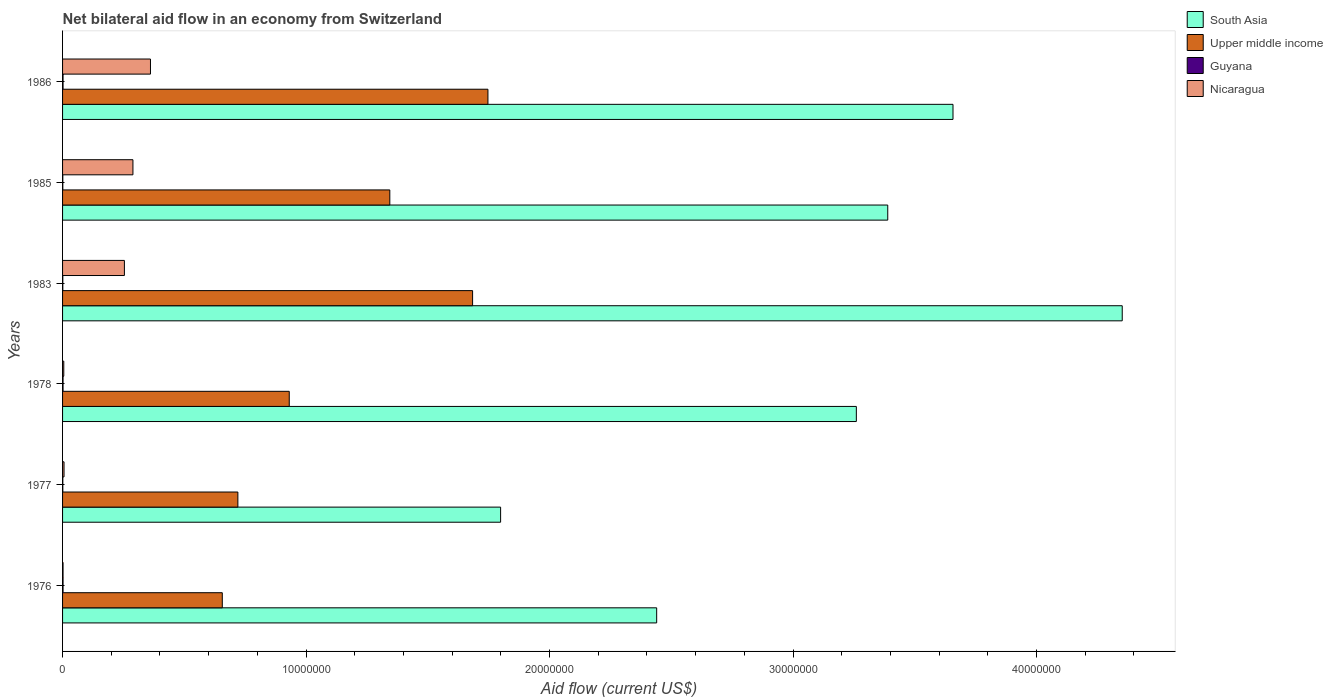How many different coloured bars are there?
Make the answer very short. 4. How many groups of bars are there?
Ensure brevity in your answer.  6. Are the number of bars per tick equal to the number of legend labels?
Offer a very short reply. Yes. Are the number of bars on each tick of the Y-axis equal?
Offer a very short reply. Yes. How many bars are there on the 6th tick from the bottom?
Offer a terse response. 4. What is the label of the 2nd group of bars from the top?
Provide a succinct answer. 1985. In how many cases, is the number of bars for a given year not equal to the number of legend labels?
Your answer should be compact. 0. What is the net bilateral aid flow in Guyana in 1985?
Your answer should be compact. 10000. Across all years, what is the maximum net bilateral aid flow in Upper middle income?
Give a very brief answer. 1.75e+07. In which year was the net bilateral aid flow in Guyana maximum?
Give a very brief answer. 1976. In which year was the net bilateral aid flow in Upper middle income minimum?
Your response must be concise. 1976. What is the total net bilateral aid flow in Upper middle income in the graph?
Your answer should be compact. 7.08e+07. What is the difference between the net bilateral aid flow in South Asia in 1976 and that in 1978?
Offer a terse response. -8.20e+06. What is the difference between the net bilateral aid flow in South Asia in 1977 and the net bilateral aid flow in Nicaragua in 1985?
Keep it short and to the point. 1.51e+07. What is the average net bilateral aid flow in South Asia per year?
Make the answer very short. 3.15e+07. In the year 1977, what is the difference between the net bilateral aid flow in Nicaragua and net bilateral aid flow in Upper middle income?
Offer a very short reply. -7.14e+06. What is the ratio of the net bilateral aid flow in Guyana in 1983 to that in 1986?
Your answer should be very brief. 0.5. Is the net bilateral aid flow in Upper middle income in 1978 less than that in 1985?
Your response must be concise. Yes. What is the difference between the highest and the lowest net bilateral aid flow in South Asia?
Provide a short and direct response. 2.55e+07. In how many years, is the net bilateral aid flow in Nicaragua greater than the average net bilateral aid flow in Nicaragua taken over all years?
Provide a succinct answer. 3. Is the sum of the net bilateral aid flow in Upper middle income in 1985 and 1986 greater than the maximum net bilateral aid flow in Nicaragua across all years?
Offer a terse response. Yes. Is it the case that in every year, the sum of the net bilateral aid flow in Upper middle income and net bilateral aid flow in Guyana is greater than the sum of net bilateral aid flow in South Asia and net bilateral aid flow in Nicaragua?
Provide a short and direct response. No. What does the 2nd bar from the top in 1986 represents?
Provide a short and direct response. Guyana. What does the 2nd bar from the bottom in 1986 represents?
Offer a terse response. Upper middle income. How many bars are there?
Provide a short and direct response. 24. Are all the bars in the graph horizontal?
Your response must be concise. Yes. How many years are there in the graph?
Provide a short and direct response. 6. What is the difference between two consecutive major ticks on the X-axis?
Ensure brevity in your answer.  1.00e+07. Are the values on the major ticks of X-axis written in scientific E-notation?
Your answer should be very brief. No. Does the graph contain any zero values?
Offer a very short reply. No. Does the graph contain grids?
Offer a terse response. No. Where does the legend appear in the graph?
Your response must be concise. Top right. How many legend labels are there?
Your answer should be very brief. 4. What is the title of the graph?
Give a very brief answer. Net bilateral aid flow in an economy from Switzerland. Does "Greece" appear as one of the legend labels in the graph?
Give a very brief answer. No. What is the label or title of the X-axis?
Offer a very short reply. Aid flow (current US$). What is the Aid flow (current US$) of South Asia in 1976?
Your answer should be compact. 2.44e+07. What is the Aid flow (current US$) of Upper middle income in 1976?
Give a very brief answer. 6.56e+06. What is the Aid flow (current US$) in Guyana in 1976?
Give a very brief answer. 2.00e+04. What is the Aid flow (current US$) in Nicaragua in 1976?
Your answer should be compact. 2.00e+04. What is the Aid flow (current US$) in South Asia in 1977?
Ensure brevity in your answer.  1.80e+07. What is the Aid flow (current US$) of Upper middle income in 1977?
Provide a short and direct response. 7.20e+06. What is the Aid flow (current US$) of Guyana in 1977?
Ensure brevity in your answer.  10000. What is the Aid flow (current US$) of South Asia in 1978?
Offer a very short reply. 3.26e+07. What is the Aid flow (current US$) of Upper middle income in 1978?
Keep it short and to the point. 9.31e+06. What is the Aid flow (current US$) in Nicaragua in 1978?
Keep it short and to the point. 5.00e+04. What is the Aid flow (current US$) of South Asia in 1983?
Make the answer very short. 4.35e+07. What is the Aid flow (current US$) in Upper middle income in 1983?
Keep it short and to the point. 1.68e+07. What is the Aid flow (current US$) in Guyana in 1983?
Make the answer very short. 10000. What is the Aid flow (current US$) in Nicaragua in 1983?
Your answer should be compact. 2.54e+06. What is the Aid flow (current US$) in South Asia in 1985?
Your answer should be very brief. 3.39e+07. What is the Aid flow (current US$) of Upper middle income in 1985?
Your answer should be compact. 1.34e+07. What is the Aid flow (current US$) in Guyana in 1985?
Keep it short and to the point. 10000. What is the Aid flow (current US$) of Nicaragua in 1985?
Your answer should be compact. 2.89e+06. What is the Aid flow (current US$) of South Asia in 1986?
Provide a short and direct response. 3.66e+07. What is the Aid flow (current US$) of Upper middle income in 1986?
Keep it short and to the point. 1.75e+07. What is the Aid flow (current US$) in Nicaragua in 1986?
Your answer should be very brief. 3.61e+06. Across all years, what is the maximum Aid flow (current US$) of South Asia?
Keep it short and to the point. 4.35e+07. Across all years, what is the maximum Aid flow (current US$) in Upper middle income?
Offer a terse response. 1.75e+07. Across all years, what is the maximum Aid flow (current US$) of Nicaragua?
Your answer should be compact. 3.61e+06. Across all years, what is the minimum Aid flow (current US$) in South Asia?
Give a very brief answer. 1.80e+07. Across all years, what is the minimum Aid flow (current US$) in Upper middle income?
Your response must be concise. 6.56e+06. Across all years, what is the minimum Aid flow (current US$) of Guyana?
Offer a very short reply. 10000. What is the total Aid flow (current US$) of South Asia in the graph?
Keep it short and to the point. 1.89e+08. What is the total Aid flow (current US$) of Upper middle income in the graph?
Provide a short and direct response. 7.08e+07. What is the total Aid flow (current US$) in Guyana in the graph?
Provide a succinct answer. 9.00e+04. What is the total Aid flow (current US$) of Nicaragua in the graph?
Your answer should be compact. 9.17e+06. What is the difference between the Aid flow (current US$) in South Asia in 1976 and that in 1977?
Your answer should be very brief. 6.41e+06. What is the difference between the Aid flow (current US$) in Upper middle income in 1976 and that in 1977?
Your response must be concise. -6.40e+05. What is the difference between the Aid flow (current US$) in Nicaragua in 1976 and that in 1977?
Your response must be concise. -4.00e+04. What is the difference between the Aid flow (current US$) of South Asia in 1976 and that in 1978?
Your answer should be compact. -8.20e+06. What is the difference between the Aid flow (current US$) in Upper middle income in 1976 and that in 1978?
Offer a terse response. -2.75e+06. What is the difference between the Aid flow (current US$) of South Asia in 1976 and that in 1983?
Provide a short and direct response. -1.91e+07. What is the difference between the Aid flow (current US$) of Upper middle income in 1976 and that in 1983?
Offer a very short reply. -1.03e+07. What is the difference between the Aid flow (current US$) of Nicaragua in 1976 and that in 1983?
Keep it short and to the point. -2.52e+06. What is the difference between the Aid flow (current US$) in South Asia in 1976 and that in 1985?
Make the answer very short. -9.49e+06. What is the difference between the Aid flow (current US$) in Upper middle income in 1976 and that in 1985?
Give a very brief answer. -6.88e+06. What is the difference between the Aid flow (current US$) of Nicaragua in 1976 and that in 1985?
Give a very brief answer. -2.87e+06. What is the difference between the Aid flow (current US$) of South Asia in 1976 and that in 1986?
Make the answer very short. -1.22e+07. What is the difference between the Aid flow (current US$) in Upper middle income in 1976 and that in 1986?
Keep it short and to the point. -1.09e+07. What is the difference between the Aid flow (current US$) of Guyana in 1976 and that in 1986?
Provide a short and direct response. 0. What is the difference between the Aid flow (current US$) in Nicaragua in 1976 and that in 1986?
Your response must be concise. -3.59e+06. What is the difference between the Aid flow (current US$) in South Asia in 1977 and that in 1978?
Provide a short and direct response. -1.46e+07. What is the difference between the Aid flow (current US$) in Upper middle income in 1977 and that in 1978?
Keep it short and to the point. -2.11e+06. What is the difference between the Aid flow (current US$) in South Asia in 1977 and that in 1983?
Offer a terse response. -2.55e+07. What is the difference between the Aid flow (current US$) in Upper middle income in 1977 and that in 1983?
Your answer should be very brief. -9.64e+06. What is the difference between the Aid flow (current US$) of Nicaragua in 1977 and that in 1983?
Offer a terse response. -2.48e+06. What is the difference between the Aid flow (current US$) of South Asia in 1977 and that in 1985?
Offer a very short reply. -1.59e+07. What is the difference between the Aid flow (current US$) in Upper middle income in 1977 and that in 1985?
Make the answer very short. -6.24e+06. What is the difference between the Aid flow (current US$) of Guyana in 1977 and that in 1985?
Keep it short and to the point. 0. What is the difference between the Aid flow (current US$) in Nicaragua in 1977 and that in 1985?
Make the answer very short. -2.83e+06. What is the difference between the Aid flow (current US$) in South Asia in 1977 and that in 1986?
Keep it short and to the point. -1.86e+07. What is the difference between the Aid flow (current US$) of Upper middle income in 1977 and that in 1986?
Keep it short and to the point. -1.03e+07. What is the difference between the Aid flow (current US$) of Guyana in 1977 and that in 1986?
Your answer should be very brief. -10000. What is the difference between the Aid flow (current US$) in Nicaragua in 1977 and that in 1986?
Offer a terse response. -3.55e+06. What is the difference between the Aid flow (current US$) of South Asia in 1978 and that in 1983?
Provide a succinct answer. -1.09e+07. What is the difference between the Aid flow (current US$) of Upper middle income in 1978 and that in 1983?
Your response must be concise. -7.53e+06. What is the difference between the Aid flow (current US$) of Nicaragua in 1978 and that in 1983?
Keep it short and to the point. -2.49e+06. What is the difference between the Aid flow (current US$) of South Asia in 1978 and that in 1985?
Your answer should be very brief. -1.29e+06. What is the difference between the Aid flow (current US$) in Upper middle income in 1978 and that in 1985?
Provide a succinct answer. -4.13e+06. What is the difference between the Aid flow (current US$) in Nicaragua in 1978 and that in 1985?
Provide a short and direct response. -2.84e+06. What is the difference between the Aid flow (current US$) in South Asia in 1978 and that in 1986?
Your answer should be very brief. -3.97e+06. What is the difference between the Aid flow (current US$) of Upper middle income in 1978 and that in 1986?
Offer a terse response. -8.16e+06. What is the difference between the Aid flow (current US$) of Guyana in 1978 and that in 1986?
Your answer should be very brief. 0. What is the difference between the Aid flow (current US$) in Nicaragua in 1978 and that in 1986?
Make the answer very short. -3.56e+06. What is the difference between the Aid flow (current US$) in South Asia in 1983 and that in 1985?
Offer a terse response. 9.63e+06. What is the difference between the Aid flow (current US$) of Upper middle income in 1983 and that in 1985?
Keep it short and to the point. 3.40e+06. What is the difference between the Aid flow (current US$) of Nicaragua in 1983 and that in 1985?
Your answer should be compact. -3.50e+05. What is the difference between the Aid flow (current US$) of South Asia in 1983 and that in 1986?
Give a very brief answer. 6.95e+06. What is the difference between the Aid flow (current US$) in Upper middle income in 1983 and that in 1986?
Make the answer very short. -6.30e+05. What is the difference between the Aid flow (current US$) of Guyana in 1983 and that in 1986?
Give a very brief answer. -10000. What is the difference between the Aid flow (current US$) of Nicaragua in 1983 and that in 1986?
Your answer should be compact. -1.07e+06. What is the difference between the Aid flow (current US$) of South Asia in 1985 and that in 1986?
Give a very brief answer. -2.68e+06. What is the difference between the Aid flow (current US$) of Upper middle income in 1985 and that in 1986?
Provide a succinct answer. -4.03e+06. What is the difference between the Aid flow (current US$) in Guyana in 1985 and that in 1986?
Offer a very short reply. -10000. What is the difference between the Aid flow (current US$) in Nicaragua in 1985 and that in 1986?
Give a very brief answer. -7.20e+05. What is the difference between the Aid flow (current US$) in South Asia in 1976 and the Aid flow (current US$) in Upper middle income in 1977?
Provide a short and direct response. 1.72e+07. What is the difference between the Aid flow (current US$) in South Asia in 1976 and the Aid flow (current US$) in Guyana in 1977?
Give a very brief answer. 2.44e+07. What is the difference between the Aid flow (current US$) in South Asia in 1976 and the Aid flow (current US$) in Nicaragua in 1977?
Provide a short and direct response. 2.43e+07. What is the difference between the Aid flow (current US$) of Upper middle income in 1976 and the Aid flow (current US$) of Guyana in 1977?
Make the answer very short. 6.55e+06. What is the difference between the Aid flow (current US$) of Upper middle income in 1976 and the Aid flow (current US$) of Nicaragua in 1977?
Your answer should be very brief. 6.50e+06. What is the difference between the Aid flow (current US$) in South Asia in 1976 and the Aid flow (current US$) in Upper middle income in 1978?
Your response must be concise. 1.51e+07. What is the difference between the Aid flow (current US$) in South Asia in 1976 and the Aid flow (current US$) in Guyana in 1978?
Offer a terse response. 2.44e+07. What is the difference between the Aid flow (current US$) of South Asia in 1976 and the Aid flow (current US$) of Nicaragua in 1978?
Your response must be concise. 2.44e+07. What is the difference between the Aid flow (current US$) of Upper middle income in 1976 and the Aid flow (current US$) of Guyana in 1978?
Ensure brevity in your answer.  6.54e+06. What is the difference between the Aid flow (current US$) in Upper middle income in 1976 and the Aid flow (current US$) in Nicaragua in 1978?
Provide a short and direct response. 6.51e+06. What is the difference between the Aid flow (current US$) in Guyana in 1976 and the Aid flow (current US$) in Nicaragua in 1978?
Offer a very short reply. -3.00e+04. What is the difference between the Aid flow (current US$) of South Asia in 1976 and the Aid flow (current US$) of Upper middle income in 1983?
Give a very brief answer. 7.56e+06. What is the difference between the Aid flow (current US$) of South Asia in 1976 and the Aid flow (current US$) of Guyana in 1983?
Your answer should be very brief. 2.44e+07. What is the difference between the Aid flow (current US$) in South Asia in 1976 and the Aid flow (current US$) in Nicaragua in 1983?
Keep it short and to the point. 2.19e+07. What is the difference between the Aid flow (current US$) of Upper middle income in 1976 and the Aid flow (current US$) of Guyana in 1983?
Keep it short and to the point. 6.55e+06. What is the difference between the Aid flow (current US$) in Upper middle income in 1976 and the Aid flow (current US$) in Nicaragua in 1983?
Provide a short and direct response. 4.02e+06. What is the difference between the Aid flow (current US$) in Guyana in 1976 and the Aid flow (current US$) in Nicaragua in 1983?
Keep it short and to the point. -2.52e+06. What is the difference between the Aid flow (current US$) in South Asia in 1976 and the Aid flow (current US$) in Upper middle income in 1985?
Give a very brief answer. 1.10e+07. What is the difference between the Aid flow (current US$) of South Asia in 1976 and the Aid flow (current US$) of Guyana in 1985?
Ensure brevity in your answer.  2.44e+07. What is the difference between the Aid flow (current US$) of South Asia in 1976 and the Aid flow (current US$) of Nicaragua in 1985?
Keep it short and to the point. 2.15e+07. What is the difference between the Aid flow (current US$) of Upper middle income in 1976 and the Aid flow (current US$) of Guyana in 1985?
Give a very brief answer. 6.55e+06. What is the difference between the Aid flow (current US$) of Upper middle income in 1976 and the Aid flow (current US$) of Nicaragua in 1985?
Ensure brevity in your answer.  3.67e+06. What is the difference between the Aid flow (current US$) in Guyana in 1976 and the Aid flow (current US$) in Nicaragua in 1985?
Your response must be concise. -2.87e+06. What is the difference between the Aid flow (current US$) of South Asia in 1976 and the Aid flow (current US$) of Upper middle income in 1986?
Offer a very short reply. 6.93e+06. What is the difference between the Aid flow (current US$) of South Asia in 1976 and the Aid flow (current US$) of Guyana in 1986?
Keep it short and to the point. 2.44e+07. What is the difference between the Aid flow (current US$) in South Asia in 1976 and the Aid flow (current US$) in Nicaragua in 1986?
Offer a very short reply. 2.08e+07. What is the difference between the Aid flow (current US$) of Upper middle income in 1976 and the Aid flow (current US$) of Guyana in 1986?
Keep it short and to the point. 6.54e+06. What is the difference between the Aid flow (current US$) of Upper middle income in 1976 and the Aid flow (current US$) of Nicaragua in 1986?
Give a very brief answer. 2.95e+06. What is the difference between the Aid flow (current US$) of Guyana in 1976 and the Aid flow (current US$) of Nicaragua in 1986?
Keep it short and to the point. -3.59e+06. What is the difference between the Aid flow (current US$) of South Asia in 1977 and the Aid flow (current US$) of Upper middle income in 1978?
Provide a succinct answer. 8.68e+06. What is the difference between the Aid flow (current US$) of South Asia in 1977 and the Aid flow (current US$) of Guyana in 1978?
Your answer should be compact. 1.80e+07. What is the difference between the Aid flow (current US$) in South Asia in 1977 and the Aid flow (current US$) in Nicaragua in 1978?
Ensure brevity in your answer.  1.79e+07. What is the difference between the Aid flow (current US$) in Upper middle income in 1977 and the Aid flow (current US$) in Guyana in 1978?
Your response must be concise. 7.18e+06. What is the difference between the Aid flow (current US$) in Upper middle income in 1977 and the Aid flow (current US$) in Nicaragua in 1978?
Provide a short and direct response. 7.15e+06. What is the difference between the Aid flow (current US$) in Guyana in 1977 and the Aid flow (current US$) in Nicaragua in 1978?
Keep it short and to the point. -4.00e+04. What is the difference between the Aid flow (current US$) of South Asia in 1977 and the Aid flow (current US$) of Upper middle income in 1983?
Provide a succinct answer. 1.15e+06. What is the difference between the Aid flow (current US$) of South Asia in 1977 and the Aid flow (current US$) of Guyana in 1983?
Make the answer very short. 1.80e+07. What is the difference between the Aid flow (current US$) in South Asia in 1977 and the Aid flow (current US$) in Nicaragua in 1983?
Your answer should be very brief. 1.54e+07. What is the difference between the Aid flow (current US$) in Upper middle income in 1977 and the Aid flow (current US$) in Guyana in 1983?
Offer a terse response. 7.19e+06. What is the difference between the Aid flow (current US$) in Upper middle income in 1977 and the Aid flow (current US$) in Nicaragua in 1983?
Make the answer very short. 4.66e+06. What is the difference between the Aid flow (current US$) of Guyana in 1977 and the Aid flow (current US$) of Nicaragua in 1983?
Provide a short and direct response. -2.53e+06. What is the difference between the Aid flow (current US$) in South Asia in 1977 and the Aid flow (current US$) in Upper middle income in 1985?
Provide a short and direct response. 4.55e+06. What is the difference between the Aid flow (current US$) in South Asia in 1977 and the Aid flow (current US$) in Guyana in 1985?
Give a very brief answer. 1.80e+07. What is the difference between the Aid flow (current US$) of South Asia in 1977 and the Aid flow (current US$) of Nicaragua in 1985?
Your answer should be very brief. 1.51e+07. What is the difference between the Aid flow (current US$) in Upper middle income in 1977 and the Aid flow (current US$) in Guyana in 1985?
Your response must be concise. 7.19e+06. What is the difference between the Aid flow (current US$) of Upper middle income in 1977 and the Aid flow (current US$) of Nicaragua in 1985?
Make the answer very short. 4.31e+06. What is the difference between the Aid flow (current US$) in Guyana in 1977 and the Aid flow (current US$) in Nicaragua in 1985?
Your response must be concise. -2.88e+06. What is the difference between the Aid flow (current US$) of South Asia in 1977 and the Aid flow (current US$) of Upper middle income in 1986?
Provide a succinct answer. 5.20e+05. What is the difference between the Aid flow (current US$) in South Asia in 1977 and the Aid flow (current US$) in Guyana in 1986?
Offer a very short reply. 1.80e+07. What is the difference between the Aid flow (current US$) in South Asia in 1977 and the Aid flow (current US$) in Nicaragua in 1986?
Keep it short and to the point. 1.44e+07. What is the difference between the Aid flow (current US$) of Upper middle income in 1977 and the Aid flow (current US$) of Guyana in 1986?
Give a very brief answer. 7.18e+06. What is the difference between the Aid flow (current US$) in Upper middle income in 1977 and the Aid flow (current US$) in Nicaragua in 1986?
Provide a succinct answer. 3.59e+06. What is the difference between the Aid flow (current US$) in Guyana in 1977 and the Aid flow (current US$) in Nicaragua in 1986?
Keep it short and to the point. -3.60e+06. What is the difference between the Aid flow (current US$) of South Asia in 1978 and the Aid flow (current US$) of Upper middle income in 1983?
Give a very brief answer. 1.58e+07. What is the difference between the Aid flow (current US$) of South Asia in 1978 and the Aid flow (current US$) of Guyana in 1983?
Offer a terse response. 3.26e+07. What is the difference between the Aid flow (current US$) in South Asia in 1978 and the Aid flow (current US$) in Nicaragua in 1983?
Provide a succinct answer. 3.01e+07. What is the difference between the Aid flow (current US$) of Upper middle income in 1978 and the Aid flow (current US$) of Guyana in 1983?
Ensure brevity in your answer.  9.30e+06. What is the difference between the Aid flow (current US$) of Upper middle income in 1978 and the Aid flow (current US$) of Nicaragua in 1983?
Your answer should be very brief. 6.77e+06. What is the difference between the Aid flow (current US$) in Guyana in 1978 and the Aid flow (current US$) in Nicaragua in 1983?
Make the answer very short. -2.52e+06. What is the difference between the Aid flow (current US$) of South Asia in 1978 and the Aid flow (current US$) of Upper middle income in 1985?
Keep it short and to the point. 1.92e+07. What is the difference between the Aid flow (current US$) of South Asia in 1978 and the Aid flow (current US$) of Guyana in 1985?
Your response must be concise. 3.26e+07. What is the difference between the Aid flow (current US$) of South Asia in 1978 and the Aid flow (current US$) of Nicaragua in 1985?
Offer a very short reply. 2.97e+07. What is the difference between the Aid flow (current US$) of Upper middle income in 1978 and the Aid flow (current US$) of Guyana in 1985?
Make the answer very short. 9.30e+06. What is the difference between the Aid flow (current US$) in Upper middle income in 1978 and the Aid flow (current US$) in Nicaragua in 1985?
Make the answer very short. 6.42e+06. What is the difference between the Aid flow (current US$) of Guyana in 1978 and the Aid flow (current US$) of Nicaragua in 1985?
Provide a short and direct response. -2.87e+06. What is the difference between the Aid flow (current US$) in South Asia in 1978 and the Aid flow (current US$) in Upper middle income in 1986?
Make the answer very short. 1.51e+07. What is the difference between the Aid flow (current US$) in South Asia in 1978 and the Aid flow (current US$) in Guyana in 1986?
Your response must be concise. 3.26e+07. What is the difference between the Aid flow (current US$) in South Asia in 1978 and the Aid flow (current US$) in Nicaragua in 1986?
Provide a short and direct response. 2.90e+07. What is the difference between the Aid flow (current US$) of Upper middle income in 1978 and the Aid flow (current US$) of Guyana in 1986?
Give a very brief answer. 9.29e+06. What is the difference between the Aid flow (current US$) in Upper middle income in 1978 and the Aid flow (current US$) in Nicaragua in 1986?
Keep it short and to the point. 5.70e+06. What is the difference between the Aid flow (current US$) in Guyana in 1978 and the Aid flow (current US$) in Nicaragua in 1986?
Offer a terse response. -3.59e+06. What is the difference between the Aid flow (current US$) of South Asia in 1983 and the Aid flow (current US$) of Upper middle income in 1985?
Your answer should be very brief. 3.01e+07. What is the difference between the Aid flow (current US$) of South Asia in 1983 and the Aid flow (current US$) of Guyana in 1985?
Your answer should be compact. 4.35e+07. What is the difference between the Aid flow (current US$) of South Asia in 1983 and the Aid flow (current US$) of Nicaragua in 1985?
Your answer should be compact. 4.06e+07. What is the difference between the Aid flow (current US$) in Upper middle income in 1983 and the Aid flow (current US$) in Guyana in 1985?
Provide a short and direct response. 1.68e+07. What is the difference between the Aid flow (current US$) in Upper middle income in 1983 and the Aid flow (current US$) in Nicaragua in 1985?
Make the answer very short. 1.40e+07. What is the difference between the Aid flow (current US$) of Guyana in 1983 and the Aid flow (current US$) of Nicaragua in 1985?
Offer a terse response. -2.88e+06. What is the difference between the Aid flow (current US$) in South Asia in 1983 and the Aid flow (current US$) in Upper middle income in 1986?
Your response must be concise. 2.60e+07. What is the difference between the Aid flow (current US$) of South Asia in 1983 and the Aid flow (current US$) of Guyana in 1986?
Offer a terse response. 4.35e+07. What is the difference between the Aid flow (current US$) of South Asia in 1983 and the Aid flow (current US$) of Nicaragua in 1986?
Keep it short and to the point. 3.99e+07. What is the difference between the Aid flow (current US$) of Upper middle income in 1983 and the Aid flow (current US$) of Guyana in 1986?
Your answer should be compact. 1.68e+07. What is the difference between the Aid flow (current US$) in Upper middle income in 1983 and the Aid flow (current US$) in Nicaragua in 1986?
Provide a succinct answer. 1.32e+07. What is the difference between the Aid flow (current US$) of Guyana in 1983 and the Aid flow (current US$) of Nicaragua in 1986?
Ensure brevity in your answer.  -3.60e+06. What is the difference between the Aid flow (current US$) of South Asia in 1985 and the Aid flow (current US$) of Upper middle income in 1986?
Keep it short and to the point. 1.64e+07. What is the difference between the Aid flow (current US$) in South Asia in 1985 and the Aid flow (current US$) in Guyana in 1986?
Ensure brevity in your answer.  3.39e+07. What is the difference between the Aid flow (current US$) of South Asia in 1985 and the Aid flow (current US$) of Nicaragua in 1986?
Make the answer very short. 3.03e+07. What is the difference between the Aid flow (current US$) of Upper middle income in 1985 and the Aid flow (current US$) of Guyana in 1986?
Your answer should be very brief. 1.34e+07. What is the difference between the Aid flow (current US$) of Upper middle income in 1985 and the Aid flow (current US$) of Nicaragua in 1986?
Provide a succinct answer. 9.83e+06. What is the difference between the Aid flow (current US$) of Guyana in 1985 and the Aid flow (current US$) of Nicaragua in 1986?
Your response must be concise. -3.60e+06. What is the average Aid flow (current US$) in South Asia per year?
Offer a very short reply. 3.15e+07. What is the average Aid flow (current US$) of Upper middle income per year?
Provide a succinct answer. 1.18e+07. What is the average Aid flow (current US$) in Guyana per year?
Provide a short and direct response. 1.50e+04. What is the average Aid flow (current US$) of Nicaragua per year?
Provide a short and direct response. 1.53e+06. In the year 1976, what is the difference between the Aid flow (current US$) of South Asia and Aid flow (current US$) of Upper middle income?
Offer a terse response. 1.78e+07. In the year 1976, what is the difference between the Aid flow (current US$) of South Asia and Aid flow (current US$) of Guyana?
Ensure brevity in your answer.  2.44e+07. In the year 1976, what is the difference between the Aid flow (current US$) in South Asia and Aid flow (current US$) in Nicaragua?
Ensure brevity in your answer.  2.44e+07. In the year 1976, what is the difference between the Aid flow (current US$) in Upper middle income and Aid flow (current US$) in Guyana?
Your answer should be very brief. 6.54e+06. In the year 1976, what is the difference between the Aid flow (current US$) in Upper middle income and Aid flow (current US$) in Nicaragua?
Offer a terse response. 6.54e+06. In the year 1976, what is the difference between the Aid flow (current US$) in Guyana and Aid flow (current US$) in Nicaragua?
Your answer should be compact. 0. In the year 1977, what is the difference between the Aid flow (current US$) in South Asia and Aid flow (current US$) in Upper middle income?
Your answer should be compact. 1.08e+07. In the year 1977, what is the difference between the Aid flow (current US$) in South Asia and Aid flow (current US$) in Guyana?
Give a very brief answer. 1.80e+07. In the year 1977, what is the difference between the Aid flow (current US$) of South Asia and Aid flow (current US$) of Nicaragua?
Give a very brief answer. 1.79e+07. In the year 1977, what is the difference between the Aid flow (current US$) of Upper middle income and Aid flow (current US$) of Guyana?
Your answer should be very brief. 7.19e+06. In the year 1977, what is the difference between the Aid flow (current US$) in Upper middle income and Aid flow (current US$) in Nicaragua?
Give a very brief answer. 7.14e+06. In the year 1978, what is the difference between the Aid flow (current US$) in South Asia and Aid flow (current US$) in Upper middle income?
Your answer should be compact. 2.33e+07. In the year 1978, what is the difference between the Aid flow (current US$) of South Asia and Aid flow (current US$) of Guyana?
Give a very brief answer. 3.26e+07. In the year 1978, what is the difference between the Aid flow (current US$) of South Asia and Aid flow (current US$) of Nicaragua?
Ensure brevity in your answer.  3.26e+07. In the year 1978, what is the difference between the Aid flow (current US$) of Upper middle income and Aid flow (current US$) of Guyana?
Your answer should be compact. 9.29e+06. In the year 1978, what is the difference between the Aid flow (current US$) of Upper middle income and Aid flow (current US$) of Nicaragua?
Ensure brevity in your answer.  9.26e+06. In the year 1983, what is the difference between the Aid flow (current US$) of South Asia and Aid flow (current US$) of Upper middle income?
Offer a terse response. 2.67e+07. In the year 1983, what is the difference between the Aid flow (current US$) of South Asia and Aid flow (current US$) of Guyana?
Give a very brief answer. 4.35e+07. In the year 1983, what is the difference between the Aid flow (current US$) of South Asia and Aid flow (current US$) of Nicaragua?
Keep it short and to the point. 4.10e+07. In the year 1983, what is the difference between the Aid flow (current US$) of Upper middle income and Aid flow (current US$) of Guyana?
Ensure brevity in your answer.  1.68e+07. In the year 1983, what is the difference between the Aid flow (current US$) of Upper middle income and Aid flow (current US$) of Nicaragua?
Your answer should be compact. 1.43e+07. In the year 1983, what is the difference between the Aid flow (current US$) in Guyana and Aid flow (current US$) in Nicaragua?
Ensure brevity in your answer.  -2.53e+06. In the year 1985, what is the difference between the Aid flow (current US$) in South Asia and Aid flow (current US$) in Upper middle income?
Your answer should be very brief. 2.04e+07. In the year 1985, what is the difference between the Aid flow (current US$) of South Asia and Aid flow (current US$) of Guyana?
Your answer should be very brief. 3.39e+07. In the year 1985, what is the difference between the Aid flow (current US$) in South Asia and Aid flow (current US$) in Nicaragua?
Ensure brevity in your answer.  3.10e+07. In the year 1985, what is the difference between the Aid flow (current US$) in Upper middle income and Aid flow (current US$) in Guyana?
Your answer should be very brief. 1.34e+07. In the year 1985, what is the difference between the Aid flow (current US$) in Upper middle income and Aid flow (current US$) in Nicaragua?
Offer a terse response. 1.06e+07. In the year 1985, what is the difference between the Aid flow (current US$) in Guyana and Aid flow (current US$) in Nicaragua?
Keep it short and to the point. -2.88e+06. In the year 1986, what is the difference between the Aid flow (current US$) in South Asia and Aid flow (current US$) in Upper middle income?
Your answer should be compact. 1.91e+07. In the year 1986, what is the difference between the Aid flow (current US$) in South Asia and Aid flow (current US$) in Guyana?
Offer a terse response. 3.66e+07. In the year 1986, what is the difference between the Aid flow (current US$) in South Asia and Aid flow (current US$) in Nicaragua?
Ensure brevity in your answer.  3.30e+07. In the year 1986, what is the difference between the Aid flow (current US$) of Upper middle income and Aid flow (current US$) of Guyana?
Your answer should be very brief. 1.74e+07. In the year 1986, what is the difference between the Aid flow (current US$) of Upper middle income and Aid flow (current US$) of Nicaragua?
Give a very brief answer. 1.39e+07. In the year 1986, what is the difference between the Aid flow (current US$) in Guyana and Aid flow (current US$) in Nicaragua?
Make the answer very short. -3.59e+06. What is the ratio of the Aid flow (current US$) of South Asia in 1976 to that in 1977?
Your answer should be very brief. 1.36. What is the ratio of the Aid flow (current US$) in Upper middle income in 1976 to that in 1977?
Give a very brief answer. 0.91. What is the ratio of the Aid flow (current US$) in Guyana in 1976 to that in 1977?
Your answer should be very brief. 2. What is the ratio of the Aid flow (current US$) of South Asia in 1976 to that in 1978?
Offer a terse response. 0.75. What is the ratio of the Aid flow (current US$) of Upper middle income in 1976 to that in 1978?
Your answer should be very brief. 0.7. What is the ratio of the Aid flow (current US$) of Nicaragua in 1976 to that in 1978?
Offer a very short reply. 0.4. What is the ratio of the Aid flow (current US$) of South Asia in 1976 to that in 1983?
Give a very brief answer. 0.56. What is the ratio of the Aid flow (current US$) of Upper middle income in 1976 to that in 1983?
Your answer should be very brief. 0.39. What is the ratio of the Aid flow (current US$) of Guyana in 1976 to that in 1983?
Your answer should be compact. 2. What is the ratio of the Aid flow (current US$) in Nicaragua in 1976 to that in 1983?
Your answer should be very brief. 0.01. What is the ratio of the Aid flow (current US$) in South Asia in 1976 to that in 1985?
Provide a succinct answer. 0.72. What is the ratio of the Aid flow (current US$) in Upper middle income in 1976 to that in 1985?
Give a very brief answer. 0.49. What is the ratio of the Aid flow (current US$) of Nicaragua in 1976 to that in 1985?
Keep it short and to the point. 0.01. What is the ratio of the Aid flow (current US$) of South Asia in 1976 to that in 1986?
Offer a terse response. 0.67. What is the ratio of the Aid flow (current US$) of Upper middle income in 1976 to that in 1986?
Keep it short and to the point. 0.38. What is the ratio of the Aid flow (current US$) of Nicaragua in 1976 to that in 1986?
Ensure brevity in your answer.  0.01. What is the ratio of the Aid flow (current US$) of South Asia in 1977 to that in 1978?
Ensure brevity in your answer.  0.55. What is the ratio of the Aid flow (current US$) of Upper middle income in 1977 to that in 1978?
Offer a terse response. 0.77. What is the ratio of the Aid flow (current US$) of Nicaragua in 1977 to that in 1978?
Your answer should be compact. 1.2. What is the ratio of the Aid flow (current US$) in South Asia in 1977 to that in 1983?
Ensure brevity in your answer.  0.41. What is the ratio of the Aid flow (current US$) in Upper middle income in 1977 to that in 1983?
Give a very brief answer. 0.43. What is the ratio of the Aid flow (current US$) of Guyana in 1977 to that in 1983?
Provide a succinct answer. 1. What is the ratio of the Aid flow (current US$) of Nicaragua in 1977 to that in 1983?
Keep it short and to the point. 0.02. What is the ratio of the Aid flow (current US$) in South Asia in 1977 to that in 1985?
Your answer should be compact. 0.53. What is the ratio of the Aid flow (current US$) in Upper middle income in 1977 to that in 1985?
Keep it short and to the point. 0.54. What is the ratio of the Aid flow (current US$) of Guyana in 1977 to that in 1985?
Ensure brevity in your answer.  1. What is the ratio of the Aid flow (current US$) in Nicaragua in 1977 to that in 1985?
Your answer should be very brief. 0.02. What is the ratio of the Aid flow (current US$) in South Asia in 1977 to that in 1986?
Offer a terse response. 0.49. What is the ratio of the Aid flow (current US$) in Upper middle income in 1977 to that in 1986?
Ensure brevity in your answer.  0.41. What is the ratio of the Aid flow (current US$) in Guyana in 1977 to that in 1986?
Provide a short and direct response. 0.5. What is the ratio of the Aid flow (current US$) in Nicaragua in 1977 to that in 1986?
Provide a succinct answer. 0.02. What is the ratio of the Aid flow (current US$) of South Asia in 1978 to that in 1983?
Provide a short and direct response. 0.75. What is the ratio of the Aid flow (current US$) in Upper middle income in 1978 to that in 1983?
Your response must be concise. 0.55. What is the ratio of the Aid flow (current US$) of Nicaragua in 1978 to that in 1983?
Keep it short and to the point. 0.02. What is the ratio of the Aid flow (current US$) in South Asia in 1978 to that in 1985?
Offer a terse response. 0.96. What is the ratio of the Aid flow (current US$) in Upper middle income in 1978 to that in 1985?
Make the answer very short. 0.69. What is the ratio of the Aid flow (current US$) in Nicaragua in 1978 to that in 1985?
Offer a terse response. 0.02. What is the ratio of the Aid flow (current US$) of South Asia in 1978 to that in 1986?
Make the answer very short. 0.89. What is the ratio of the Aid flow (current US$) of Upper middle income in 1978 to that in 1986?
Give a very brief answer. 0.53. What is the ratio of the Aid flow (current US$) of Guyana in 1978 to that in 1986?
Your answer should be very brief. 1. What is the ratio of the Aid flow (current US$) in Nicaragua in 1978 to that in 1986?
Make the answer very short. 0.01. What is the ratio of the Aid flow (current US$) in South Asia in 1983 to that in 1985?
Your answer should be very brief. 1.28. What is the ratio of the Aid flow (current US$) in Upper middle income in 1983 to that in 1985?
Provide a succinct answer. 1.25. What is the ratio of the Aid flow (current US$) of Nicaragua in 1983 to that in 1985?
Provide a succinct answer. 0.88. What is the ratio of the Aid flow (current US$) in South Asia in 1983 to that in 1986?
Give a very brief answer. 1.19. What is the ratio of the Aid flow (current US$) in Upper middle income in 1983 to that in 1986?
Offer a terse response. 0.96. What is the ratio of the Aid flow (current US$) in Nicaragua in 1983 to that in 1986?
Offer a terse response. 0.7. What is the ratio of the Aid flow (current US$) of South Asia in 1985 to that in 1986?
Make the answer very short. 0.93. What is the ratio of the Aid flow (current US$) of Upper middle income in 1985 to that in 1986?
Your answer should be compact. 0.77. What is the ratio of the Aid flow (current US$) in Guyana in 1985 to that in 1986?
Your answer should be compact. 0.5. What is the ratio of the Aid flow (current US$) in Nicaragua in 1985 to that in 1986?
Your answer should be very brief. 0.8. What is the difference between the highest and the second highest Aid flow (current US$) of South Asia?
Make the answer very short. 6.95e+06. What is the difference between the highest and the second highest Aid flow (current US$) of Upper middle income?
Give a very brief answer. 6.30e+05. What is the difference between the highest and the second highest Aid flow (current US$) of Guyana?
Offer a very short reply. 0. What is the difference between the highest and the second highest Aid flow (current US$) in Nicaragua?
Your response must be concise. 7.20e+05. What is the difference between the highest and the lowest Aid flow (current US$) in South Asia?
Offer a very short reply. 2.55e+07. What is the difference between the highest and the lowest Aid flow (current US$) in Upper middle income?
Your response must be concise. 1.09e+07. What is the difference between the highest and the lowest Aid flow (current US$) of Guyana?
Your answer should be compact. 10000. What is the difference between the highest and the lowest Aid flow (current US$) of Nicaragua?
Keep it short and to the point. 3.59e+06. 